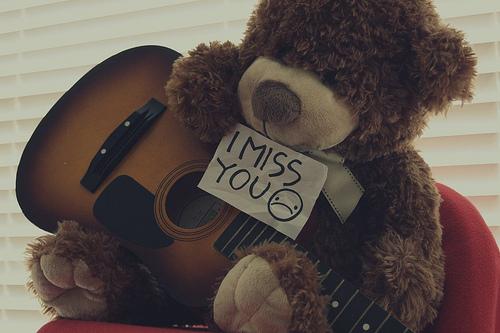What instrument is the bear holding?
Give a very brief answer. Guitar. Is it day or night?
Answer briefly. Day. Does the bear miss someone?
Concise answer only. Yes. 